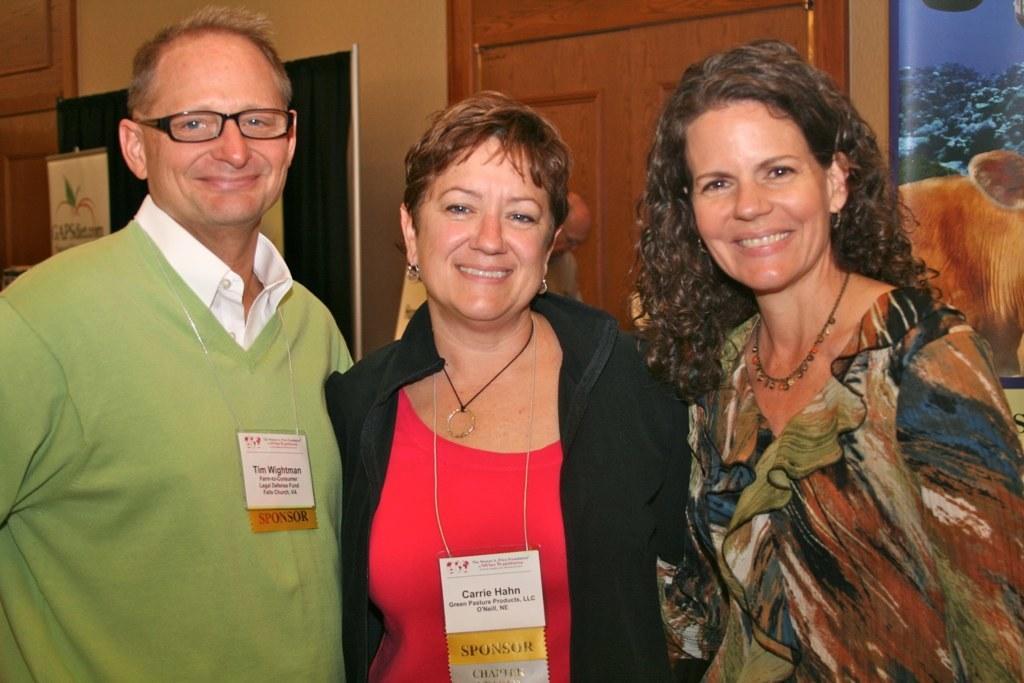How would you summarize this image in a sentence or two? In this image in the front there are persons standing and smiling. In the background there is a door and there are frames on the wall and there is curtain which is black in colour and on the curtain there are banners with some text written on it. 